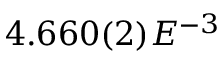<formula> <loc_0><loc_0><loc_500><loc_500>4 . 6 6 0 ( 2 ) E ^ { - 3 }</formula> 